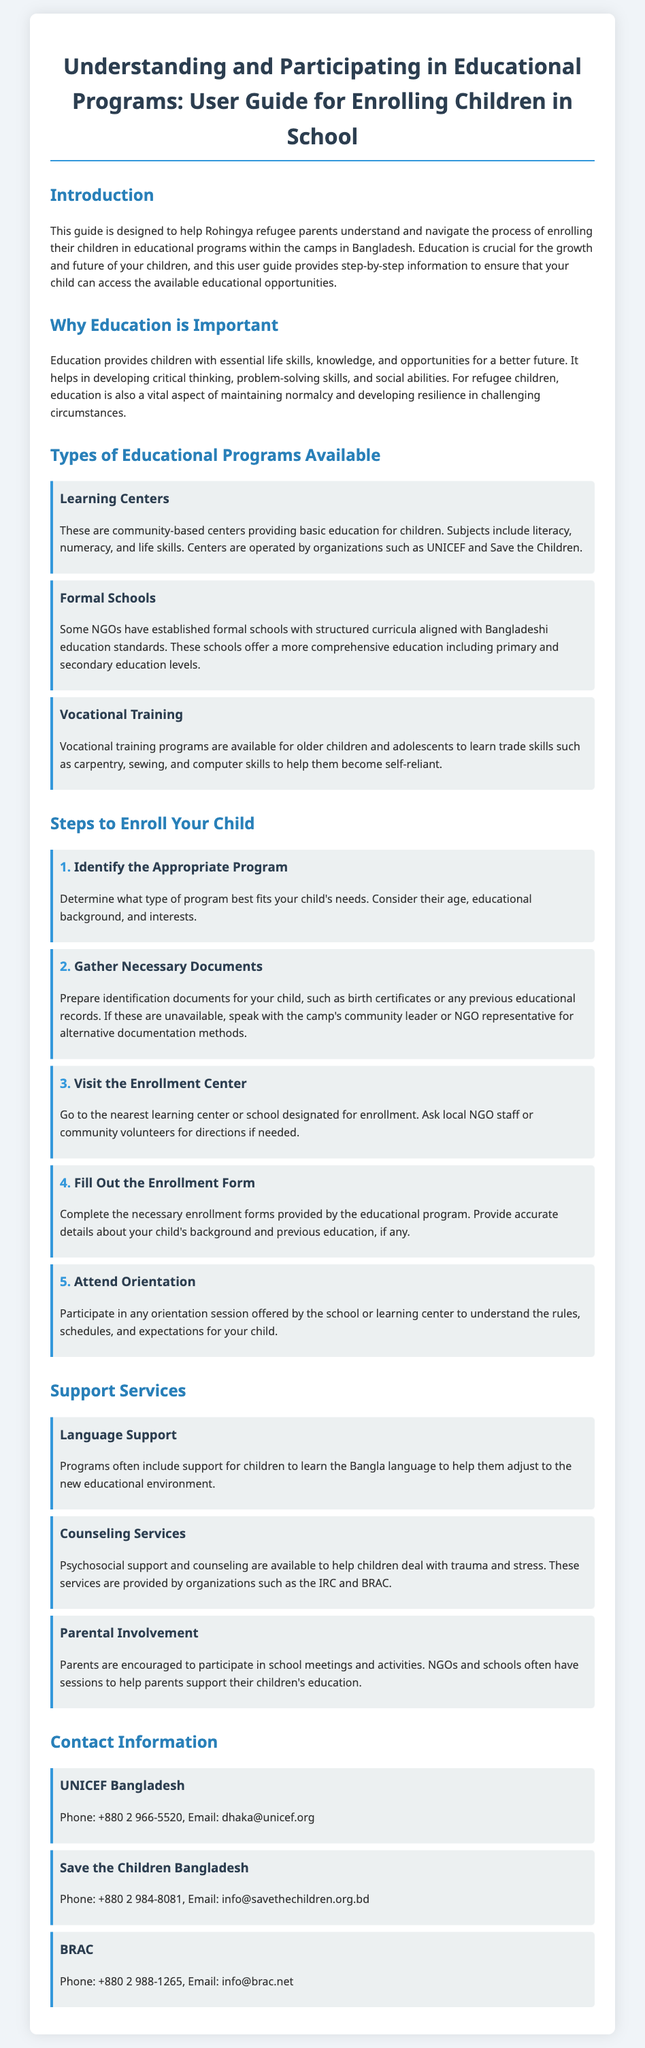What is the title of the guide? The title of the guide is presented at the beginning of the document.
Answer: Understanding and Participating in Educational Programs: User Guide for Enrolling Children in School What organization operates Learning Centers? The document specifies the organizations that run Learning Centers.
Answer: UNICEF and Save the Children How many steps are there to enroll your child? The guide lists the steps needed for the enrollment process.
Answer: Five What type of training is available for older children? The section specifies the educational opportunity for older children and adolescents.
Answer: Vocational Training What kind of support does the document mention for language? The document helps identify types of support services offered for children.
Answer: Language Support What is a requirement before filling out the enrollment form? The document mentions necessary preparations before form completion.
Answer: Gather Necessary Documents What participation is encouraged from parents? The guide explains the involvement expected from parents in the educational process.
Answer: Parental Involvement Who can you contact for support from UNICEF? The contact information section provides a point of contact for assistance.
Answer: dhaka@unicef.org 